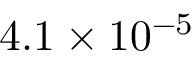Convert formula to latex. <formula><loc_0><loc_0><loc_500><loc_500>4 . 1 \times 1 0 ^ { - 5 }</formula> 